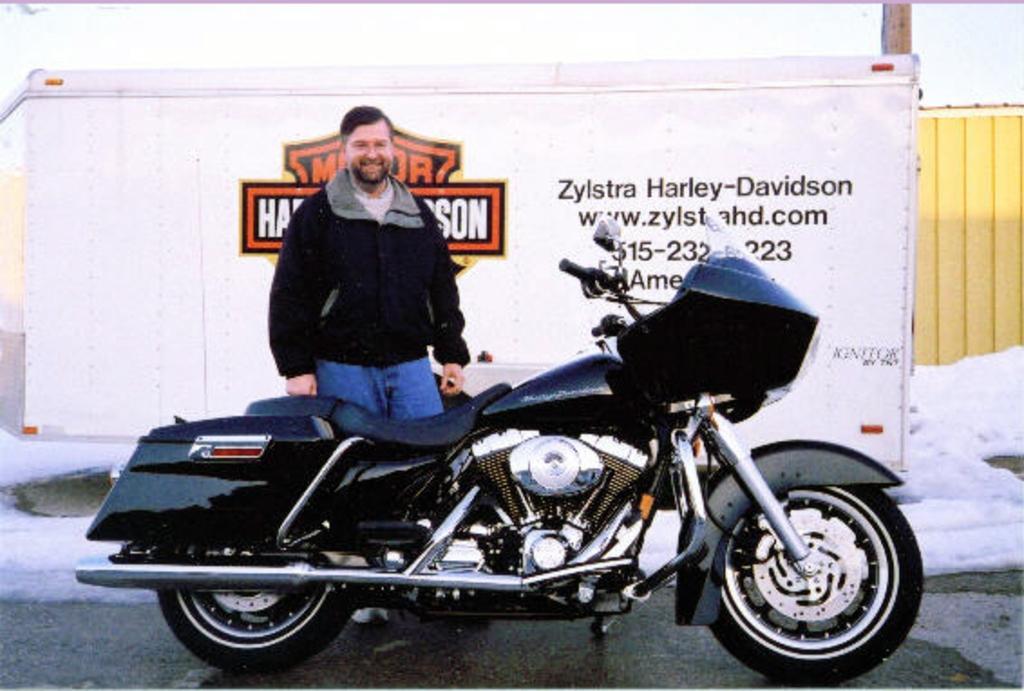Please provide a concise description of this image. In this image there is a bike on a road, behind the bike there is a man standing, in the background there is a board, on that board there is some text and there is snow. 